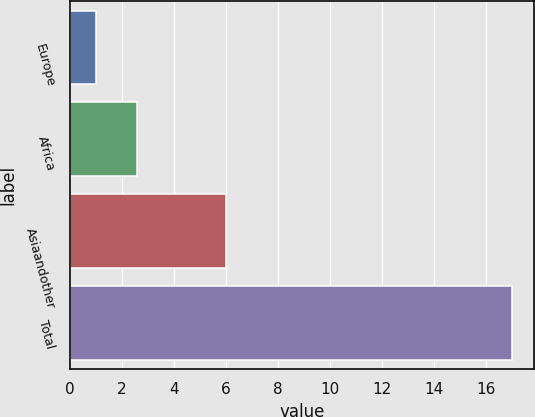Convert chart. <chart><loc_0><loc_0><loc_500><loc_500><bar_chart><fcel>Europe<fcel>Africa<fcel>Asiaandother<fcel>Total<nl><fcel>1<fcel>2.6<fcel>6<fcel>17<nl></chart> 